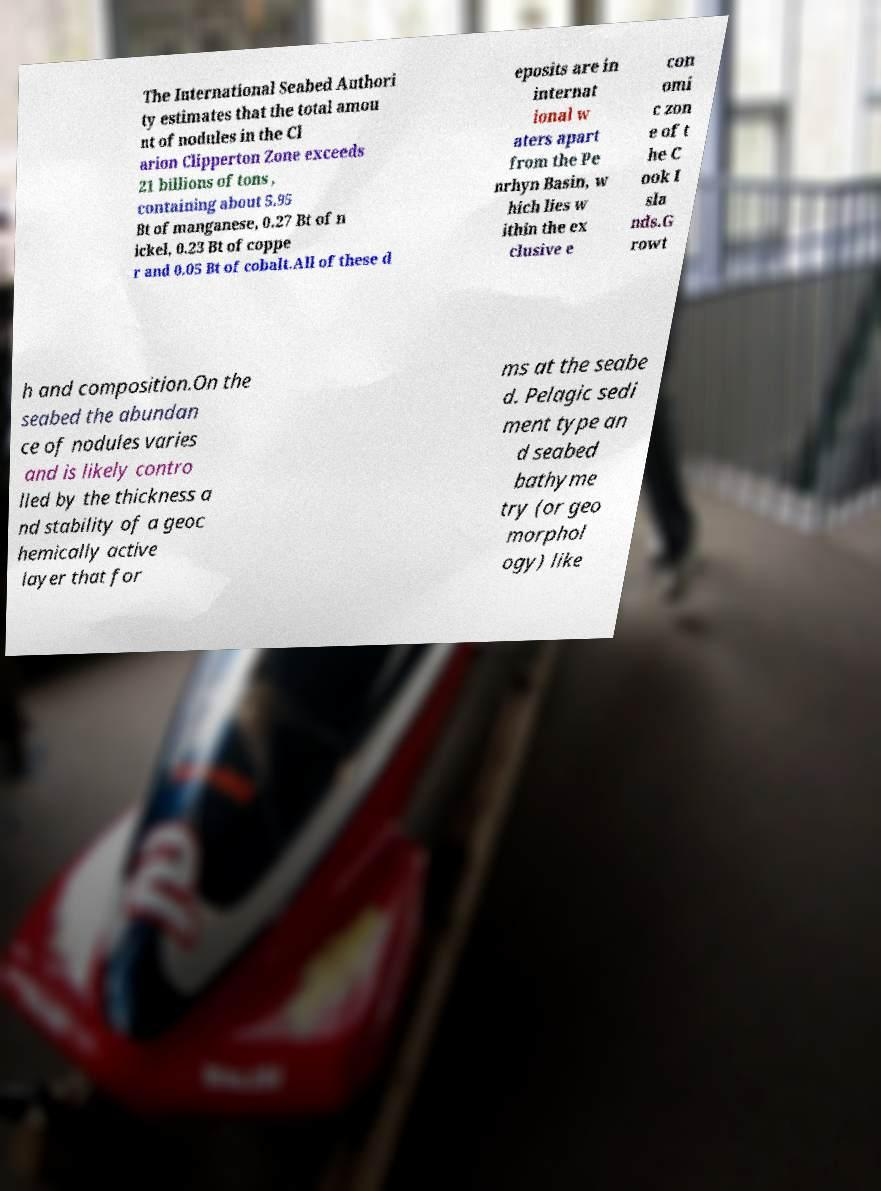There's text embedded in this image that I need extracted. Can you transcribe it verbatim? The International Seabed Authori ty estimates that the total amou nt of nodules in the Cl arion Clipperton Zone exceeds 21 billions of tons , containing about 5.95 Bt of manganese, 0.27 Bt of n ickel, 0.23 Bt of coppe r and 0.05 Bt of cobalt.All of these d eposits are in internat ional w aters apart from the Pe nrhyn Basin, w hich lies w ithin the ex clusive e con omi c zon e of t he C ook I sla nds.G rowt h and composition.On the seabed the abundan ce of nodules varies and is likely contro lled by the thickness a nd stability of a geoc hemically active layer that for ms at the seabe d. Pelagic sedi ment type an d seabed bathyme try (or geo morphol ogy) like 